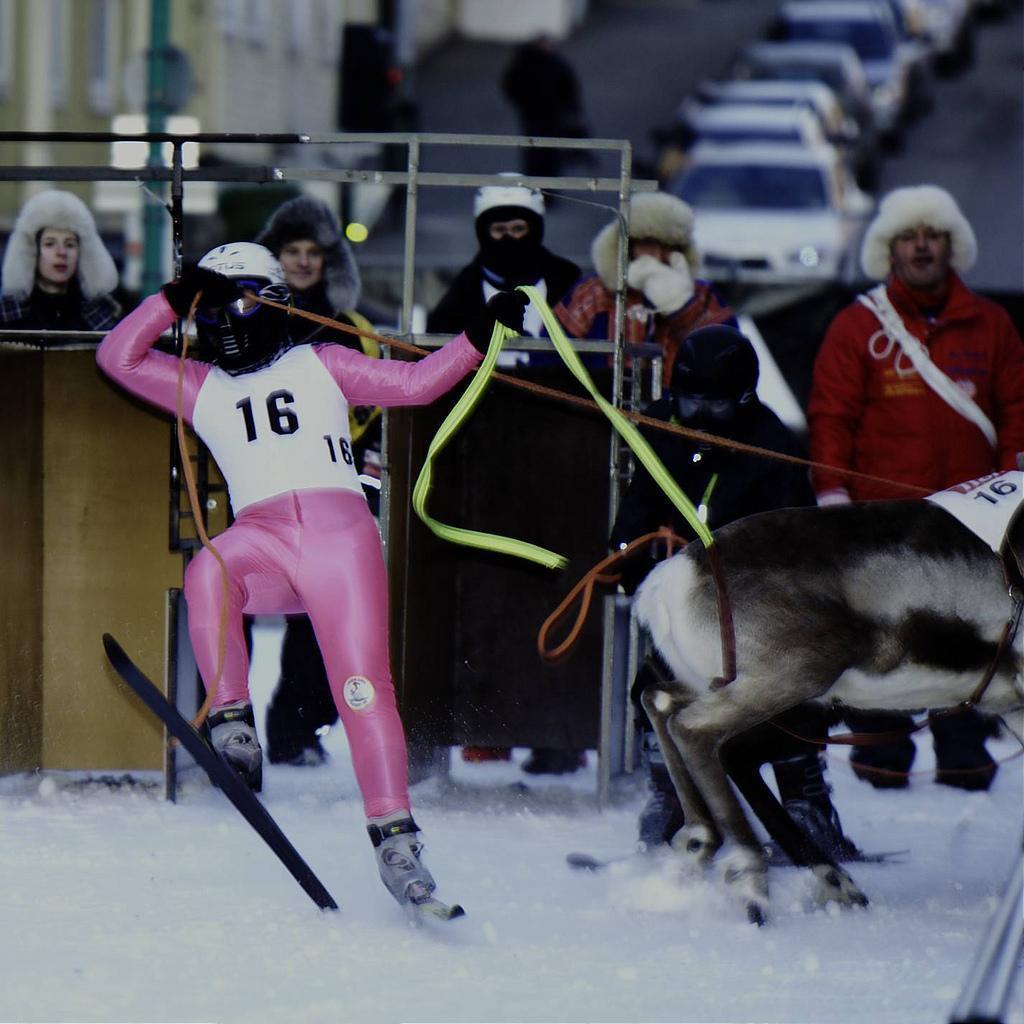How many people are wearing helmets?
Give a very brief answer. 2. 